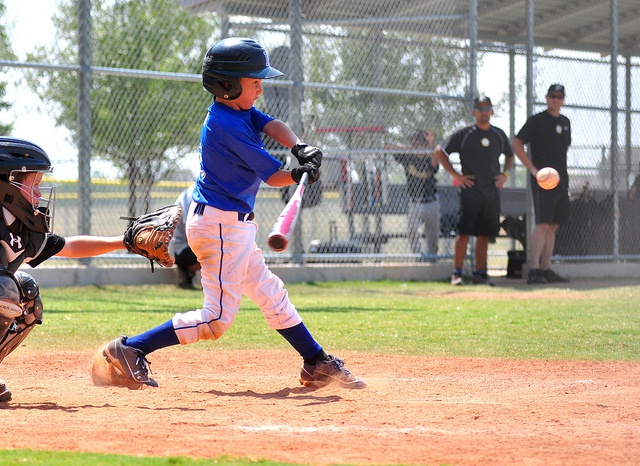Describe the objects in this image and their specific colors. I can see people in lightgray, navy, black, lightpink, and lavender tones, people in lightgray, black, maroon, brown, and white tones, people in lightgray, black, gray, maroon, and brown tones, people in lightgray, black, gray, and white tones, and people in lightgray, gray, darkgray, and black tones in this image. 